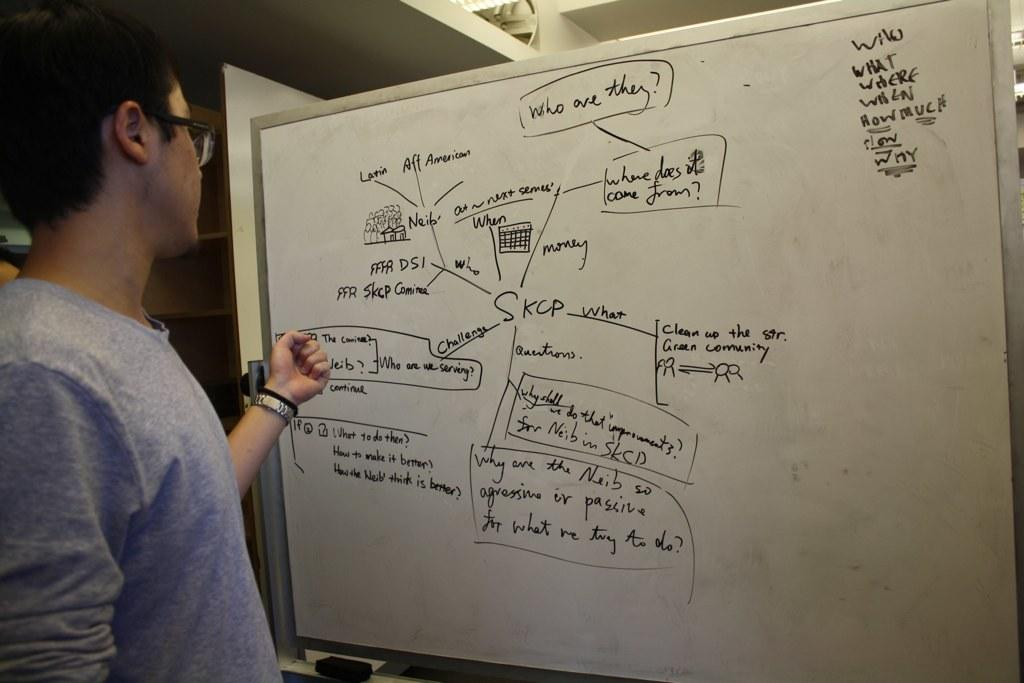<image>
Render a clear and concise summary of the photo. A man stands in front of a white board with a diagram that stems out from the word "SKCP" in the middle. 